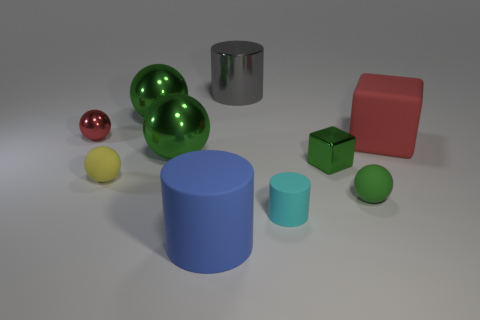What is the size of the rubber cube that is the same color as the small shiny ball?
Give a very brief answer. Large. What number of green metallic things are both on the right side of the big gray cylinder and left of the big blue matte cylinder?
Provide a short and direct response. 0. How many red things are the same material as the big blue object?
Offer a terse response. 1. What color is the block that is made of the same material as the large blue thing?
Offer a terse response. Red. Is the number of blue rubber cylinders less than the number of green things?
Provide a succinct answer. Yes. What is the large object that is on the right side of the green thing that is on the right side of the green shiny object that is on the right side of the gray cylinder made of?
Ensure brevity in your answer.  Rubber. What is the green block made of?
Provide a short and direct response. Metal. Does the large thing on the right side of the green rubber sphere have the same color as the tiny shiny thing that is on the left side of the metallic cylinder?
Provide a succinct answer. Yes. Are there more small gray shiny things than large gray cylinders?
Your response must be concise. No. What number of large objects have the same color as the tiny shiny ball?
Your response must be concise. 1. 